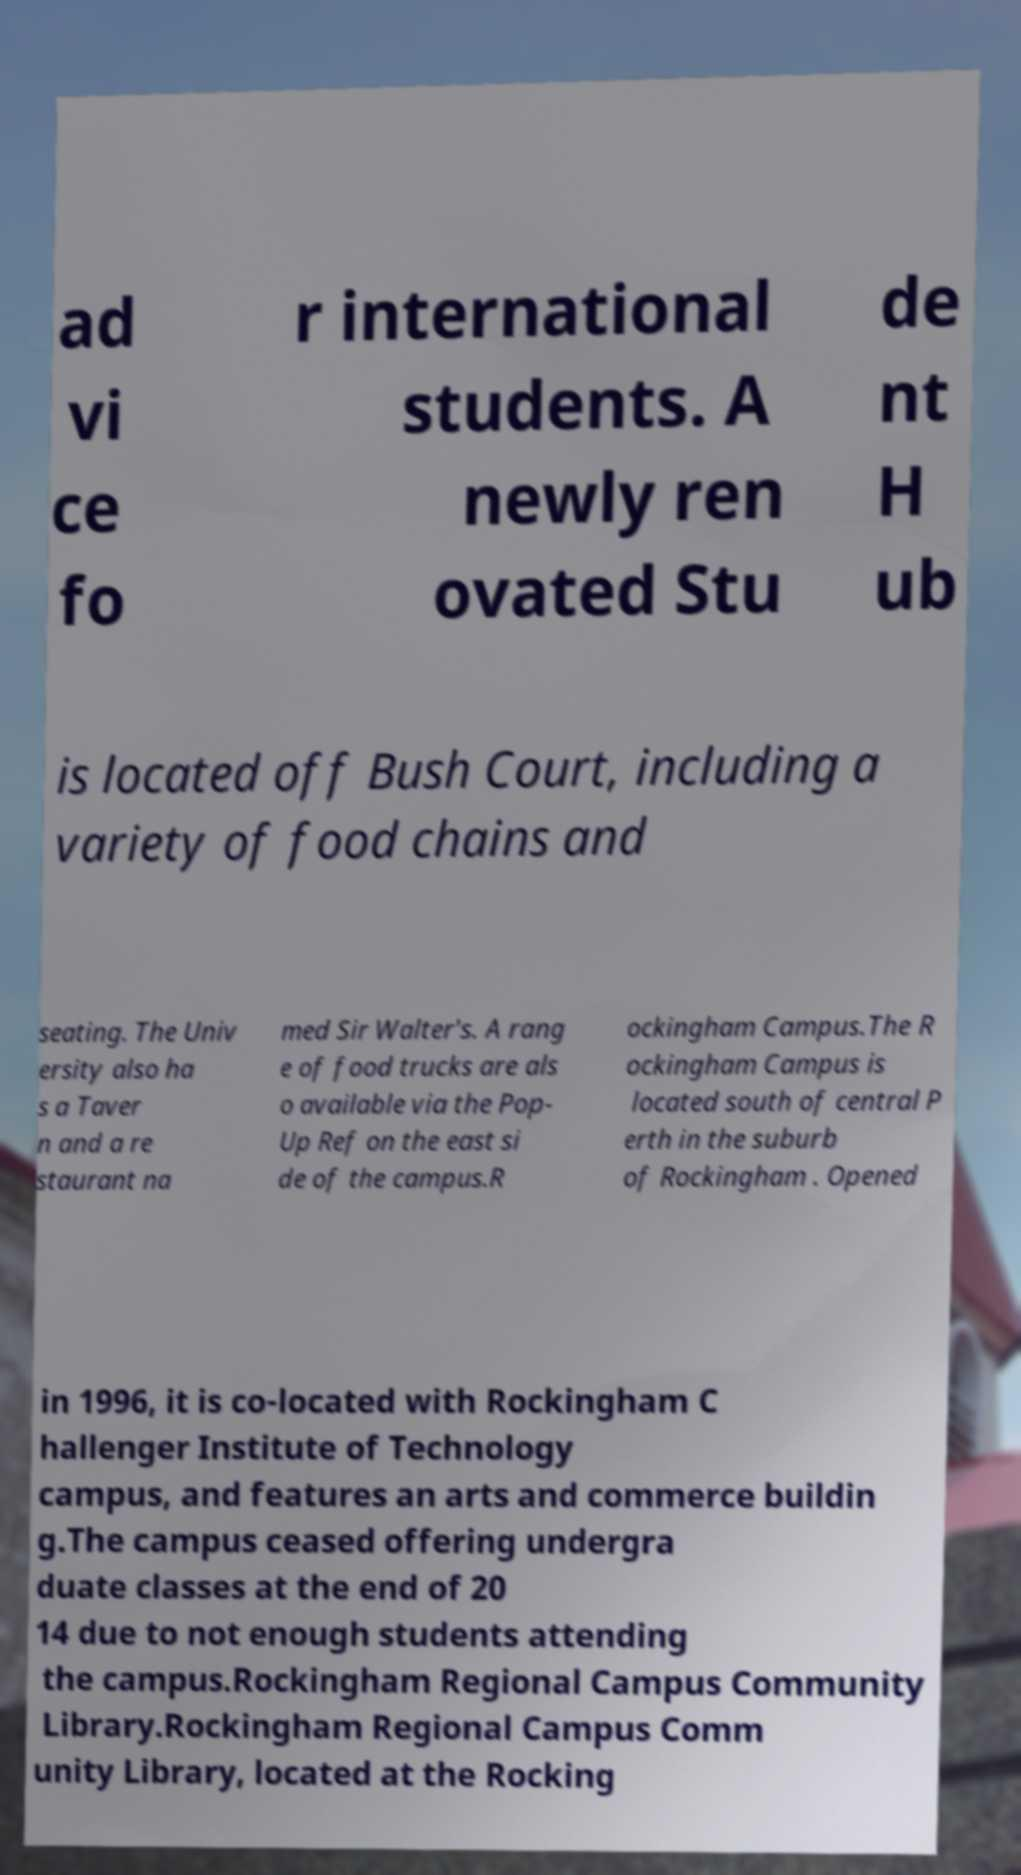There's text embedded in this image that I need extracted. Can you transcribe it verbatim? ad vi ce fo r international students. A newly ren ovated Stu de nt H ub is located off Bush Court, including a variety of food chains and seating. The Univ ersity also ha s a Taver n and a re staurant na med Sir Walter's. A rang e of food trucks are als o available via the Pop- Up Ref on the east si de of the campus.R ockingham Campus.The R ockingham Campus is located south of central P erth in the suburb of Rockingham . Opened in 1996, it is co-located with Rockingham C hallenger Institute of Technology campus, and features an arts and commerce buildin g.The campus ceased offering undergra duate classes at the end of 20 14 due to not enough students attending the campus.Rockingham Regional Campus Community Library.Rockingham Regional Campus Comm unity Library, located at the Rocking 